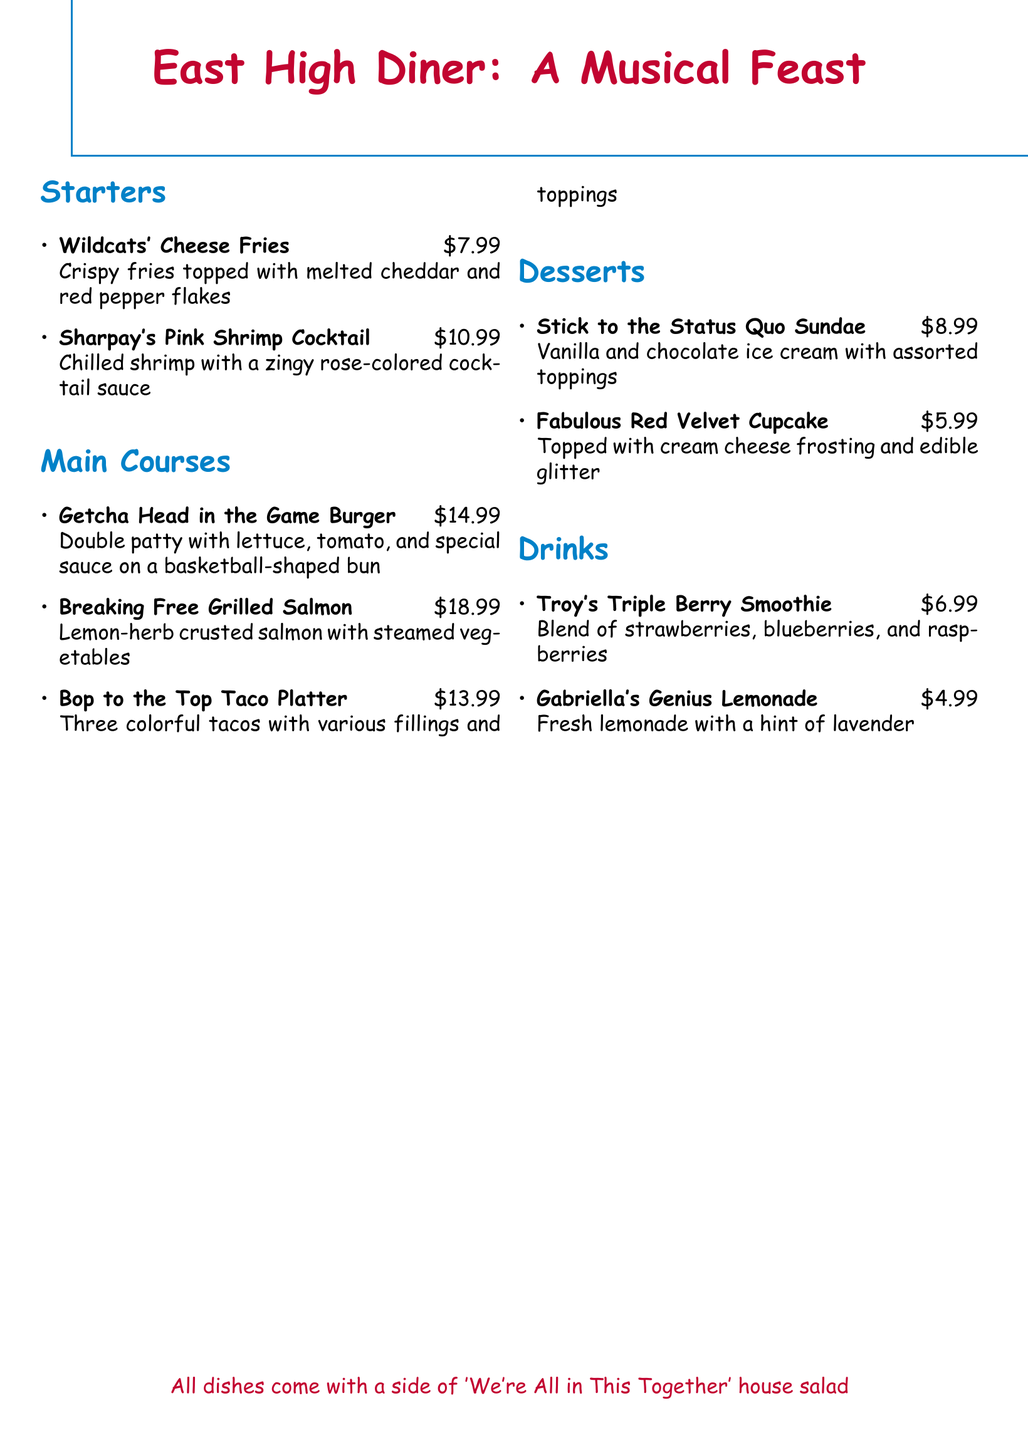What is the name of the starter dish that includes shrimp? The document lists "Sharpay's Pink Shrimp Cocktail" as a starter dish that includes shrimp.
Answer: Sharpay's Pink Shrimp Cocktail How much does the Getcha Head in the Game Burger cost? The price for the Getcha Head in the Game Burger is stated in the menu as $14.99.
Answer: $14.99 What type of dessert is the Fabulous Red Velvet Cupcake? The menu describes the Fabulous Red Velvet Cupcake as topped with cream cheese frosting and edible glitter, indicating its type as a cupcake.
Answer: Cupcake Which drink is made with a blend of berries? The menu specifies "Troy's Triple Berry Smoothie" as the drink made with a blend of strawberries, blueberries, and raspberries.
Answer: Troy's Triple Berry Smoothie How many tacos are included in the Bop to the Top Taco Platter? The menu mentions that the Bop to the Top Taco Platter includes three tacos.
Answer: Three What is included as a side with all dishes? The menu states that all dishes come with a side of "We're All in This Together" house salad.
Answer: We're All in This Together house salad Which main course features salmon? The menu lists "Breaking Free Grilled Salmon" as the main course featuring salmon.
Answer: Breaking Free Grilled Salmon What color is the special cocktail sauce for the shrimp? The document describes the cocktail sauce as rose-colored.
Answer: Rose-colored 